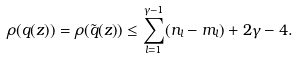Convert formula to latex. <formula><loc_0><loc_0><loc_500><loc_500>\rho ( q ( z ) ) = \rho ( { \tilde { q } ( z ) } ) \leq \sum _ { l = 1 } ^ { \gamma - 1 } ( n _ { l } - m _ { l } ) + 2 \gamma - 4 .</formula> 